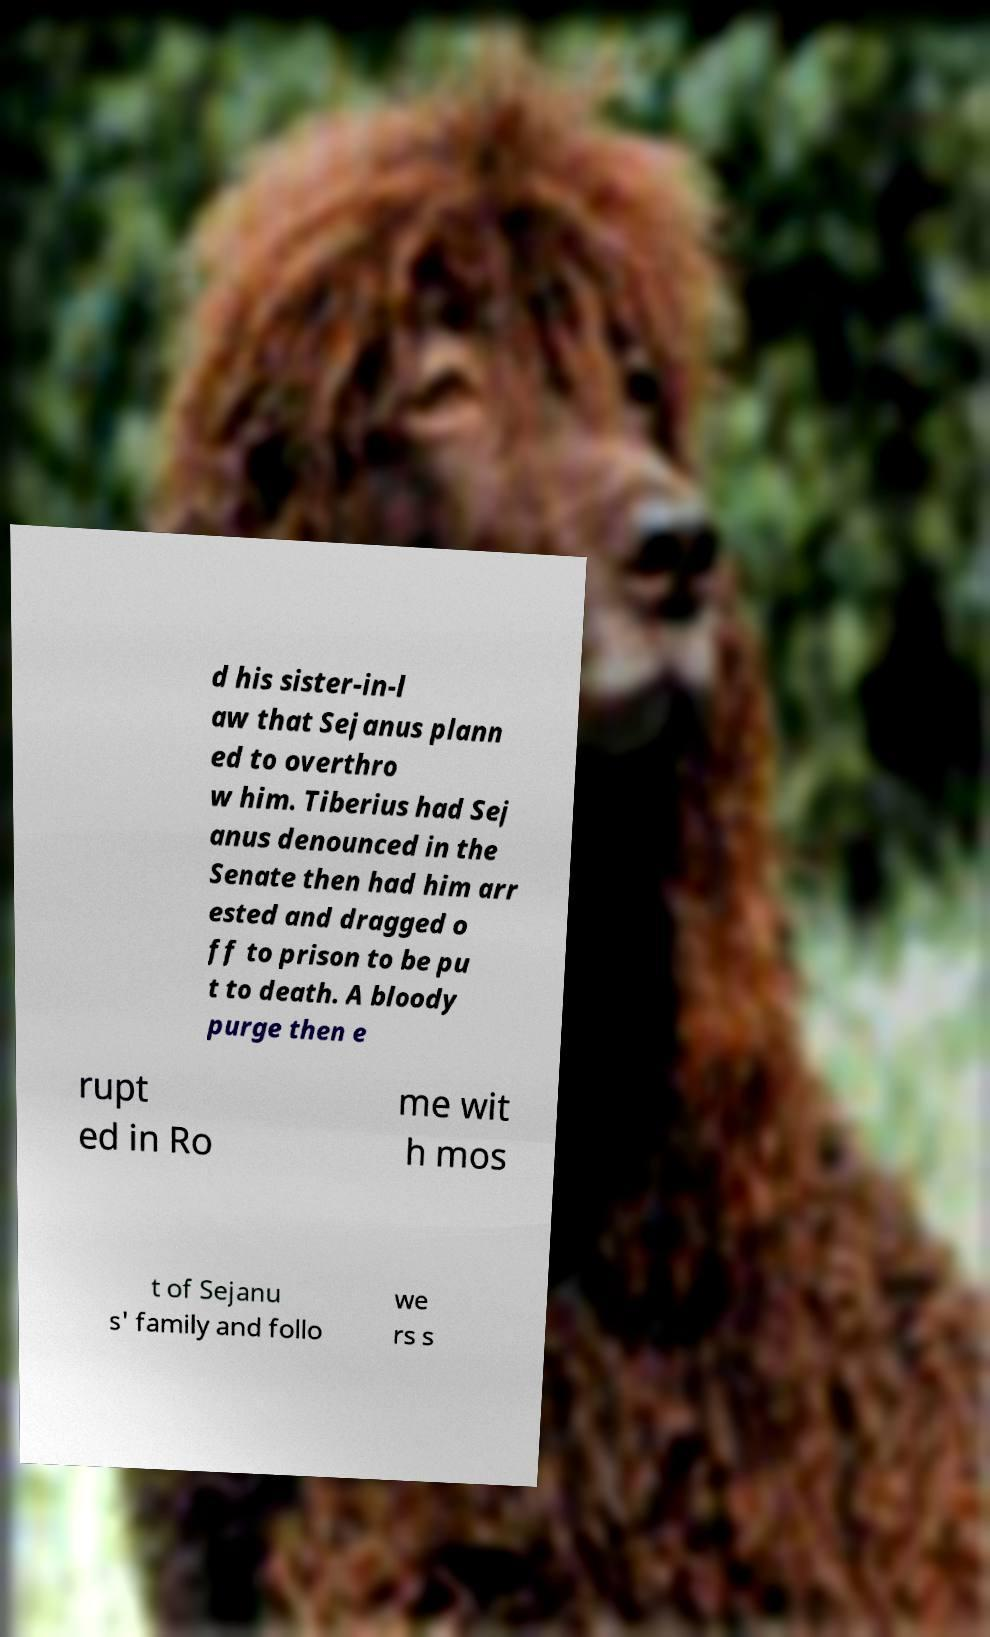Please identify and transcribe the text found in this image. d his sister-in-l aw that Sejanus plann ed to overthro w him. Tiberius had Sej anus denounced in the Senate then had him arr ested and dragged o ff to prison to be pu t to death. A bloody purge then e rupt ed in Ro me wit h mos t of Sejanu s' family and follo we rs s 